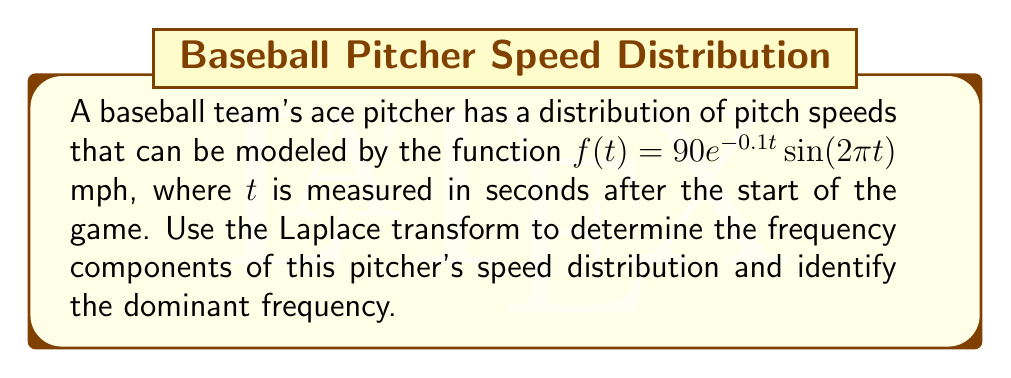Could you help me with this problem? To analyze the frequency distribution using Laplace transforms, we'll follow these steps:

1) First, let's recall the Laplace transform of $f(t) = 90e^{-0.1t}\sin(2\pi t)$:

   $$\mathcal{L}\{90e^{-0.1t}\sin(2\pi t)\} = 90 \cdot \frac{2\pi}{(s+0.1)^2 + (2\pi)^2}$$

2) The Laplace transform gives us the complex frequency response. To find the magnitude of the frequency response, we replace $s$ with $j\omega$:

   $$H(j\omega) = 90 \cdot \frac{2\pi}{(j\omega+0.1)^2 + (2\pi)^2}$$

3) The magnitude of this frequency response is:

   $$|H(j\omega)| = 90 \cdot \frac{2\pi}{\sqrt{(\omega^2-4\pi^2+0.01)^2 + 0.4\omega^2}}$$

4) To find the dominant frequency, we need to find the maximum of this function. We can do this by differentiating with respect to $\omega$ and setting it to zero, but that's quite complex. Instead, we can observe that the denominator will be smallest (and thus $|H(j\omega)|$ will be largest) when $\omega^2-4\pi^2+0.01 \approx 0$.

5) Solving this:

   $$\omega^2 \approx 4\pi^2 - 0.01 \approx 4\pi^2$$
   $$\omega \approx 2\pi$$

6) This means the dominant frequency is approximately $2\pi$ radians per second, or 1 Hz.

7) This aligns with our original function $90e^{-0.1t}\sin(2\pi t)$, where the sine term has a frequency of $2\pi$.
Answer: The dominant frequency in the pitcher's speed distribution is approximately 1 Hz (one cycle per second). 